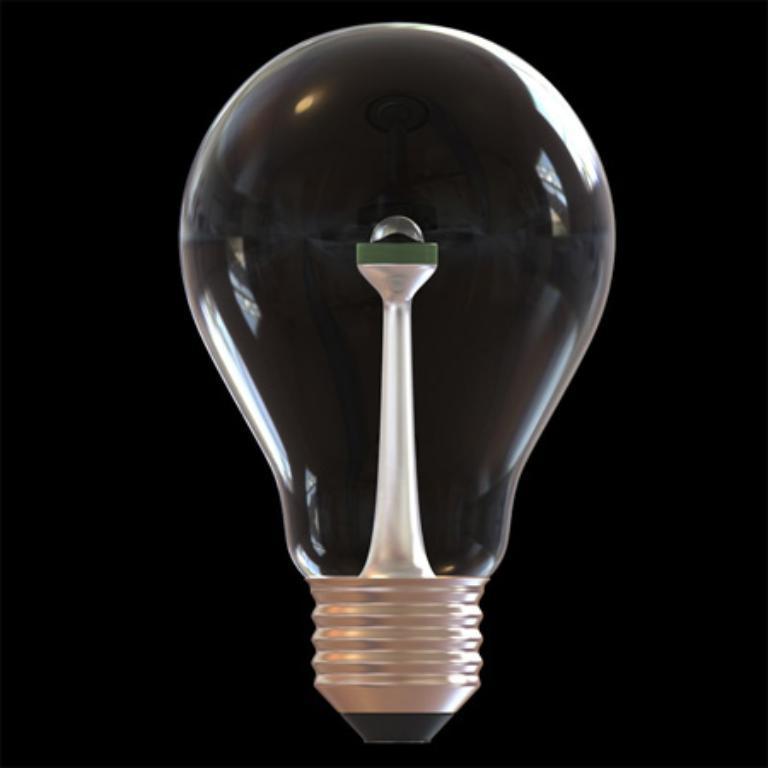Please provide a concise description of this image. As we can see in the image in the front there is a light and the background is dark. 